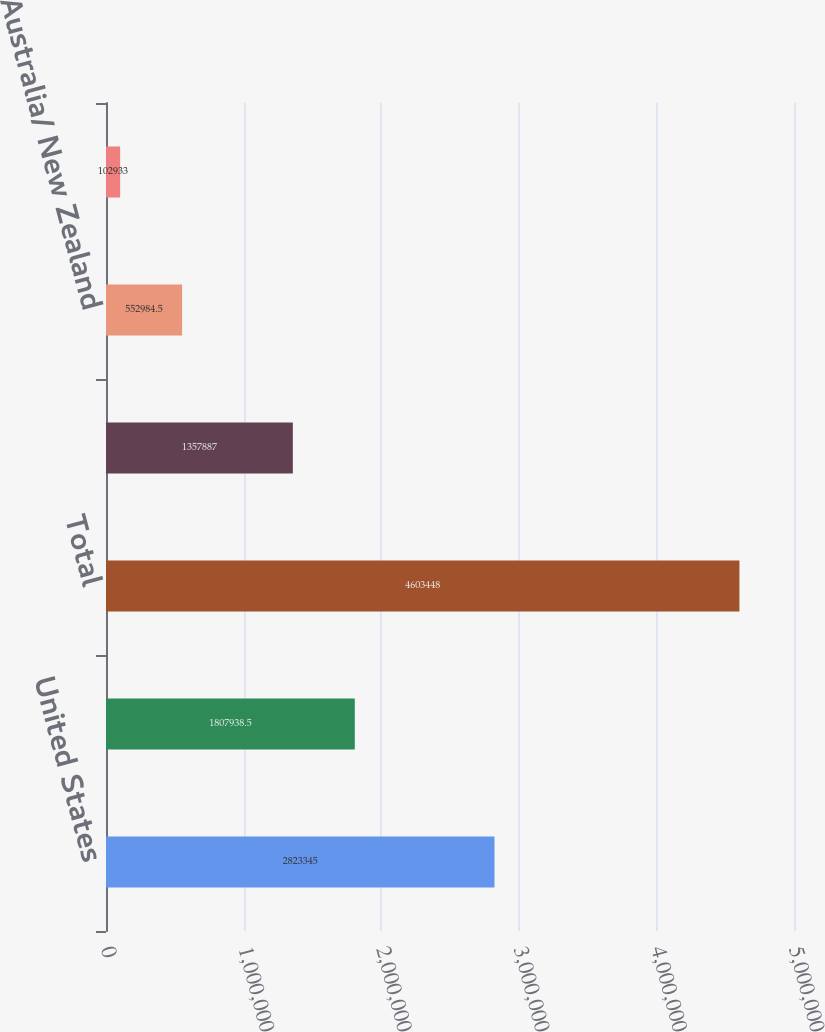Convert chart to OTSL. <chart><loc_0><loc_0><loc_500><loc_500><bar_chart><fcel>United States<fcel>Non-US<fcel>Total<fcel>United Kingdom<fcel>Australia/ New Zealand<fcel>Other<nl><fcel>2.82334e+06<fcel>1.80794e+06<fcel>4.60345e+06<fcel>1.35789e+06<fcel>552984<fcel>102933<nl></chart> 